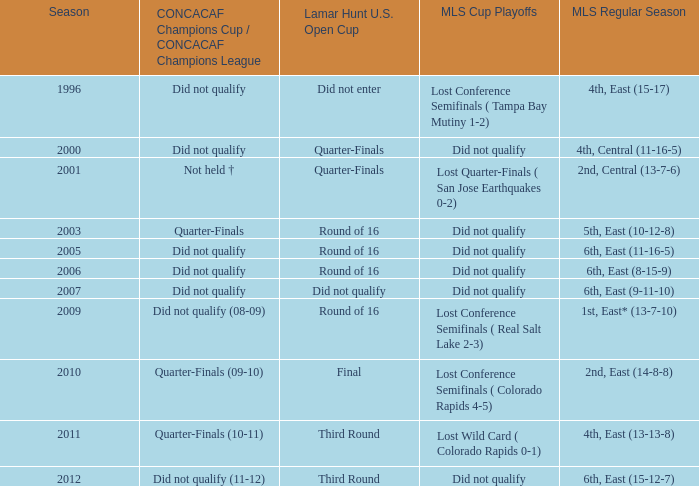How many entries are there for season where mls regular season was 5th, east (10-12-8)? 1.0. 